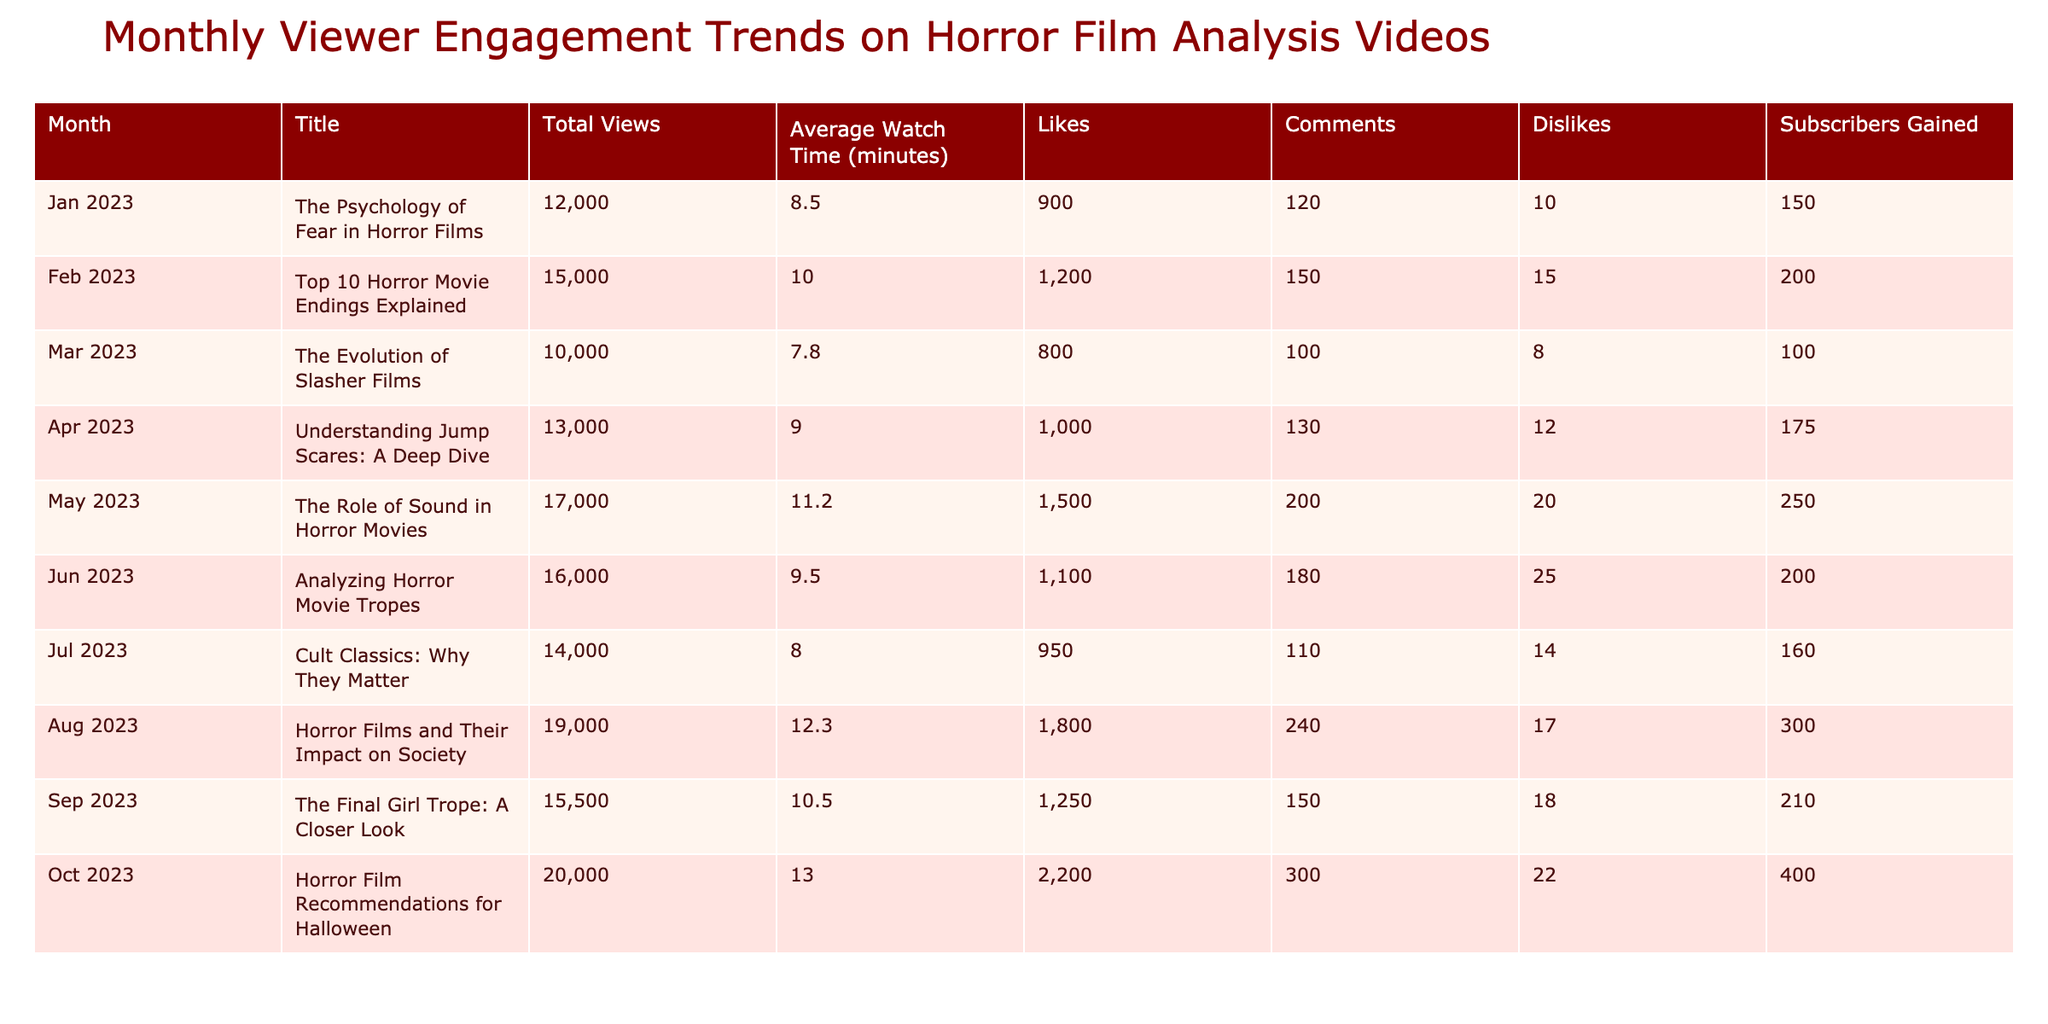What was the total number of views in May 2023? In the table, under the "Total Views" column for May 2023, the value is listed as 17,000.
Answer: 17,000 Which video had the highest average watch time? Upon reviewing the "Average Watch Time (minutes)" column, the video "Horror Film Recommendations for Halloween" in October 2023 has the highest average watch time at 13.0 minutes.
Answer: 13.0 minutes How many total likes did the videos receive from January to April 2023? We sum the likes from each month: January (900) + February (1,200) + March (800) + April (1,000) = 3,900.
Answer: 3,900 Is the average watch time in June 2023 greater than the average watch time in March 2023? In June 2023, the average watch time is 9.5 minutes, and in March 2023, it is 7.8 minutes. Since 9.5 is greater than 7.8, the statement is true.
Answer: Yes What is the total number of subscribers gained in August and September 2023? The number of subscribers gained in August is 300 and in September is 210. Adding them gives 300 + 210 = 510.
Answer: 510 Which month saw the highest number of dislikes? Looking at the "Dislikes" column, the video "The Role of Sound in Horror Movies" in May 2023 shows the highest dislikes, totaling 20.
Answer: 20 What is the average number of comments across all videos analyzed? To find the average, we first sum the number of comments: 120 (Jan) + 150 (Feb) + 100 (Mar) + 130 (Apr) + 200 (May) + 180 (Jun) + 110 (Jul) + 240 (Aug) + 150 (Sep) + 300 (Oct) = 1,680. There are 10 months, so we divide: 1,680 / 10 = 168.
Answer: 168 Was there a higher number of likes for the video in April than for the video in January? In April 2023, the video received 1,000 likes, while in January 2023 it received 900 likes. Since 1,000 is greater than 900, the statement is true.
Answer: Yes What is the difference in total views between the video from October 2023 and that from March 2023? The total views for October 2023 is 20,000, and for March 2023 it is 10,000. The difference is 20,000 - 10,000 = 10,000.
Answer: 10,000 